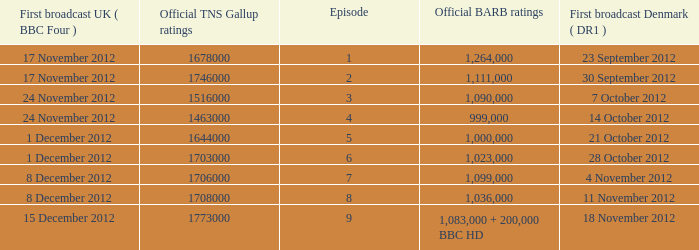When was the episode with a 999,000 BARB rating first aired in Denmark? 14 October 2012. 